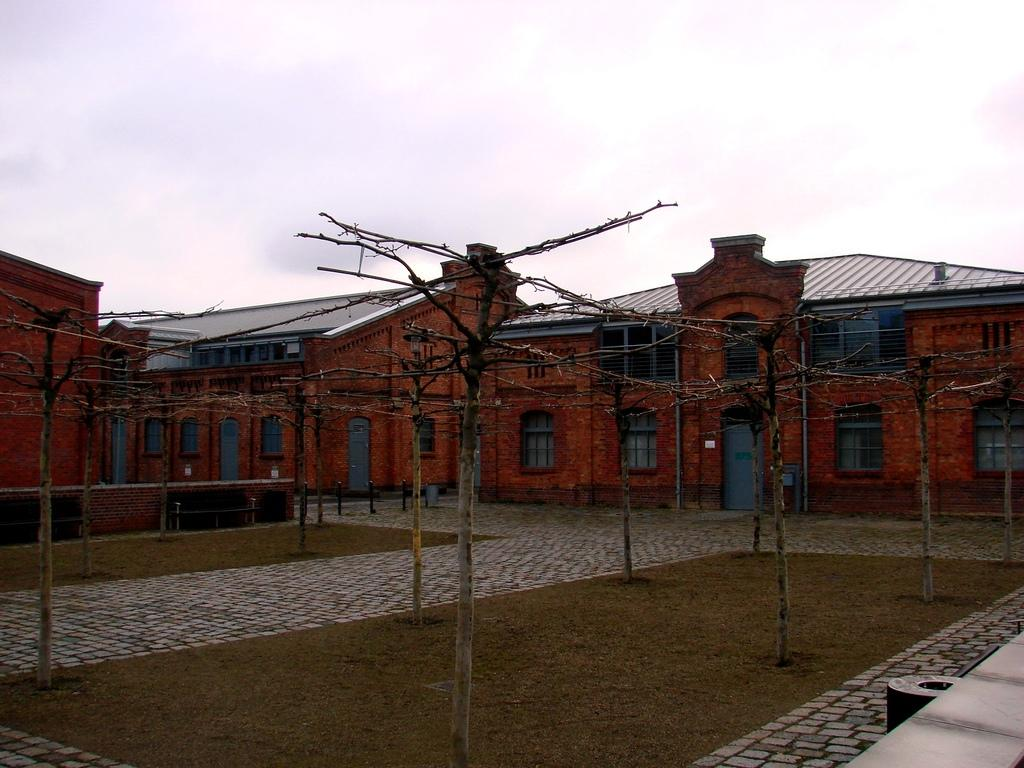What type of structures can be seen in the image? There are houses in the image. What features can be observed on the houses? There are windows and doors visible on the houses. What other objects can be seen in the image? There are poles in the image. What can be seen beneath the houses? The ground is visible in the image. What is visible in the background of the image? There is sky visible in the background of the image. What type of bottle can be seen in the image? There is no bottle present in the image. What type of soup is being served in the image? There is no soup present in the image. 